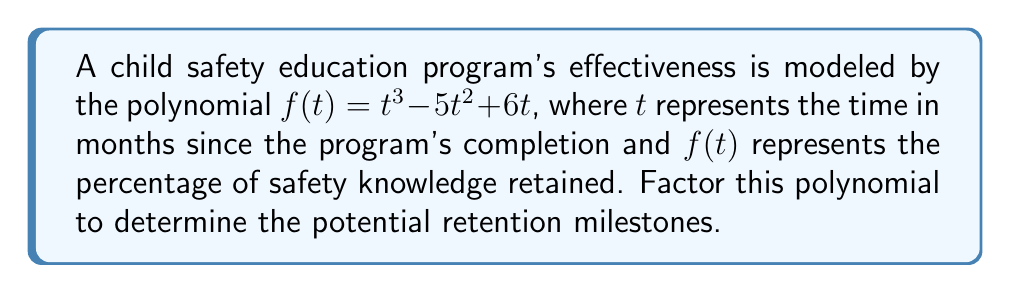What is the answer to this math problem? To factor this polynomial, we'll follow these steps:

1) First, let's check if there's a common factor:
   $f(t) = t^3 - 5t^2 + 6t$
   We can factor out $t$:
   $f(t) = t(t^2 - 5t + 6)$

2) Now we have $t(t^2 - 5t + 6)$. We need to factor the quadratic part $(t^2 - 5t + 6)$.

3) For a quadratic in the form $at^2 + bt + c$, we look for two numbers that multiply to give $ac$ and add to give $b$.
   Here, $a=1$, $b=-5$, and $c=6$.
   We need two numbers that multiply to give $1 * 6 = 6$ and add to give $-5$.
   These numbers are $-2$ and $-3$.

4) We can rewrite the middle term using these numbers:
   $t^2 - 2t - 3t + 6$

5) Now we can factor by grouping:
   $(t^2 - 2t) + (-3t + 6)$
   $t(t - 2) - 3(t - 2)$
   $(t - 2)(t - 3)$

6) Combining this with the $t$ we factored out in step 1, our final factored form is:
   $f(t) = t(t - 2)(t - 3)$

This factorization suggests that the retention milestones occur at 0, 2, and 3 months after the program's completion.
Answer: $f(t) = t(t - 2)(t - 3)$ 